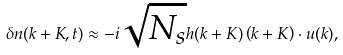Convert formula to latex. <formula><loc_0><loc_0><loc_500><loc_500>\delta n ( k + K , t ) \approx - i \sqrt { N _ { s } } h ( k + K ) \left ( k + K \right ) \cdot u ( k ) ,</formula> 